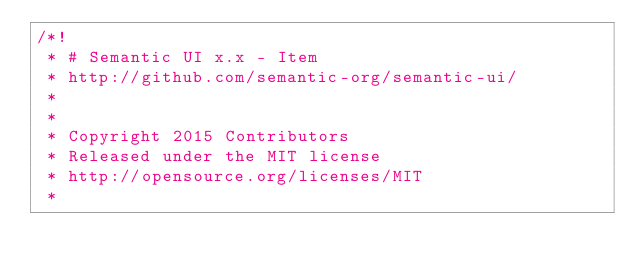Convert code to text. <code><loc_0><loc_0><loc_500><loc_500><_CSS_>/*!
 * # Semantic UI x.x - Item
 * http://github.com/semantic-org/semantic-ui/
 *
 *
 * Copyright 2015 Contributors
 * Released under the MIT license
 * http://opensource.org/licenses/MIT
 *</code> 